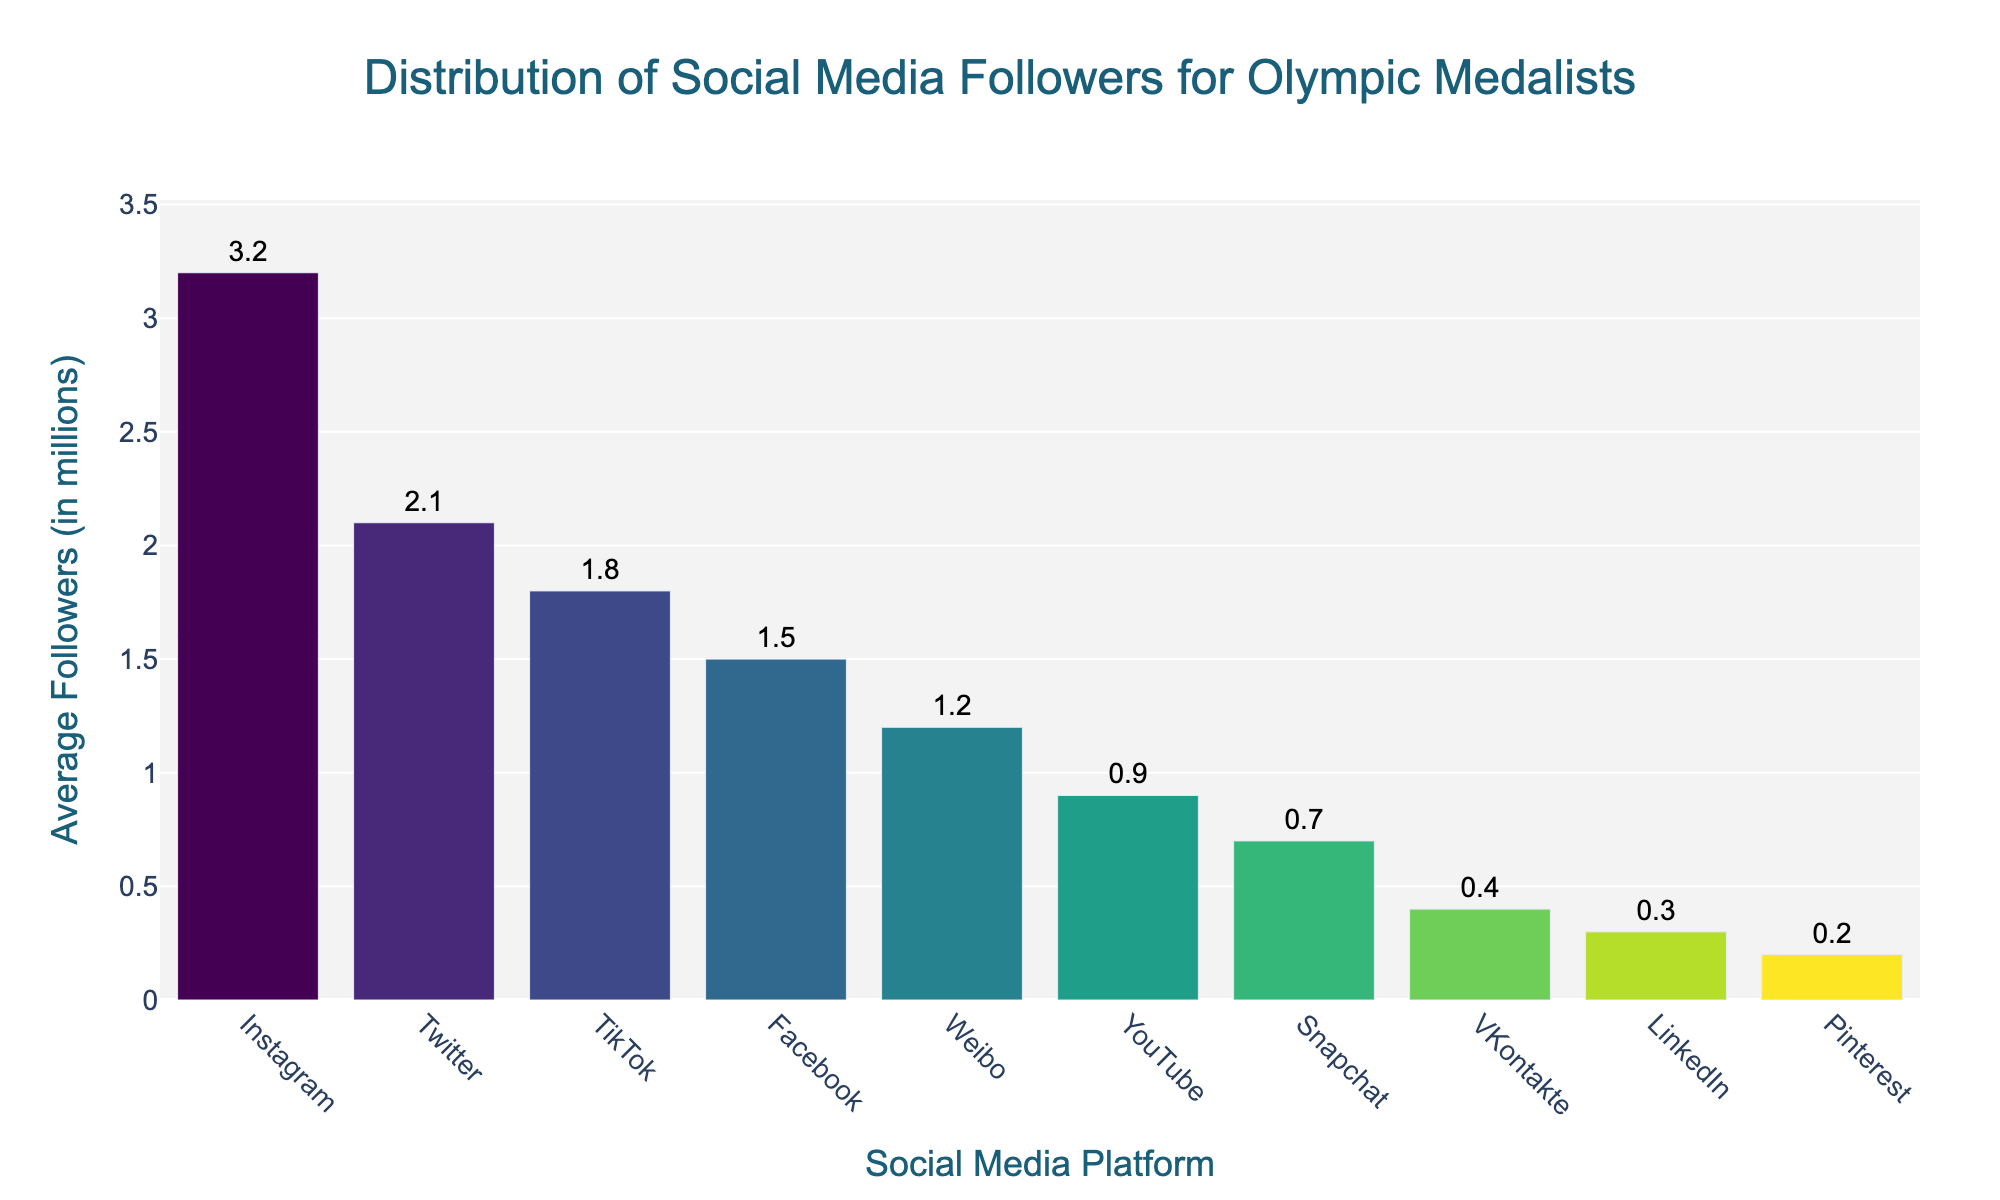Which platform has the highest average number of followers? The tallest bar in the bar chart corresponds to the platform with the highest average number of followers. The platform at the top is Instagram.
Answer: Instagram Which platform has fewer average followers: Facebook or YouTube? To determine this, compare the heights of the bars for Facebook and YouTube. The bar for Facebook is taller than the bar for YouTube.
Answer: YouTube What's the difference in average followers between Twitter and LinkedIn? Subtract the average followers of LinkedIn (0.3 million) from the average followers of Twitter (2.1 million). 2.1 - 0.3 = 1.8 million.
Answer: 1.8 million Which platforms have an average follower count above 2 million? Platforms with bars that extend above the 2 million mark are Instagram and Twitter.
Answer: Instagram, Twitter Which platform has the closest average followers to 1 million? Looking at the platform bars around the 1 million mark, YouTube, with 0.9 million followers, is closest to 1 million.
Answer: YouTube How many platforms have an average follower count below 1 million? Count the number of bars that are shorter than the 1 million mark. These are YouTube (0.9), LinkedIn (0.3), Snapchat (0.7), VKontakte (0.4), and Pinterest (0.2). There are 5 platforms.
Answer: 5 What is the combined average followers for TikTok and Weibo? Sum the average followers for TikTok (1.8 million) and Weibo (1.2 million). 1.8 + 1.2 = 3.0 million.
Answer: 3.0 million How does the average number of followers on Snapchat compare to that on VKontakte? Compare the heights of the bars for Snapchat and VKontakte. The bar for Snapchat is taller than that of VKontakte.
Answer: Snapchat has more What's the average of the average followers across the top three platforms? The average followers for the top three platforms are Instagram (3.2 million), Twitter (2.1 million), and TikTok (1.8 million). Calculate the average: (3.2 + 2.1 + 1.8) / 3 = 2.3667 million.
Answer: 2.4 million Which platform occupies the median position in terms of average followers? To find the median, order the platforms by followers: Instagram, Twitter, TikTok, Weibo, Facebook, YouTube, Snapchat, VKontakte, LinkedIn, Pinterest. The median is the 5th platform: Facebook.
Answer: Facebook 